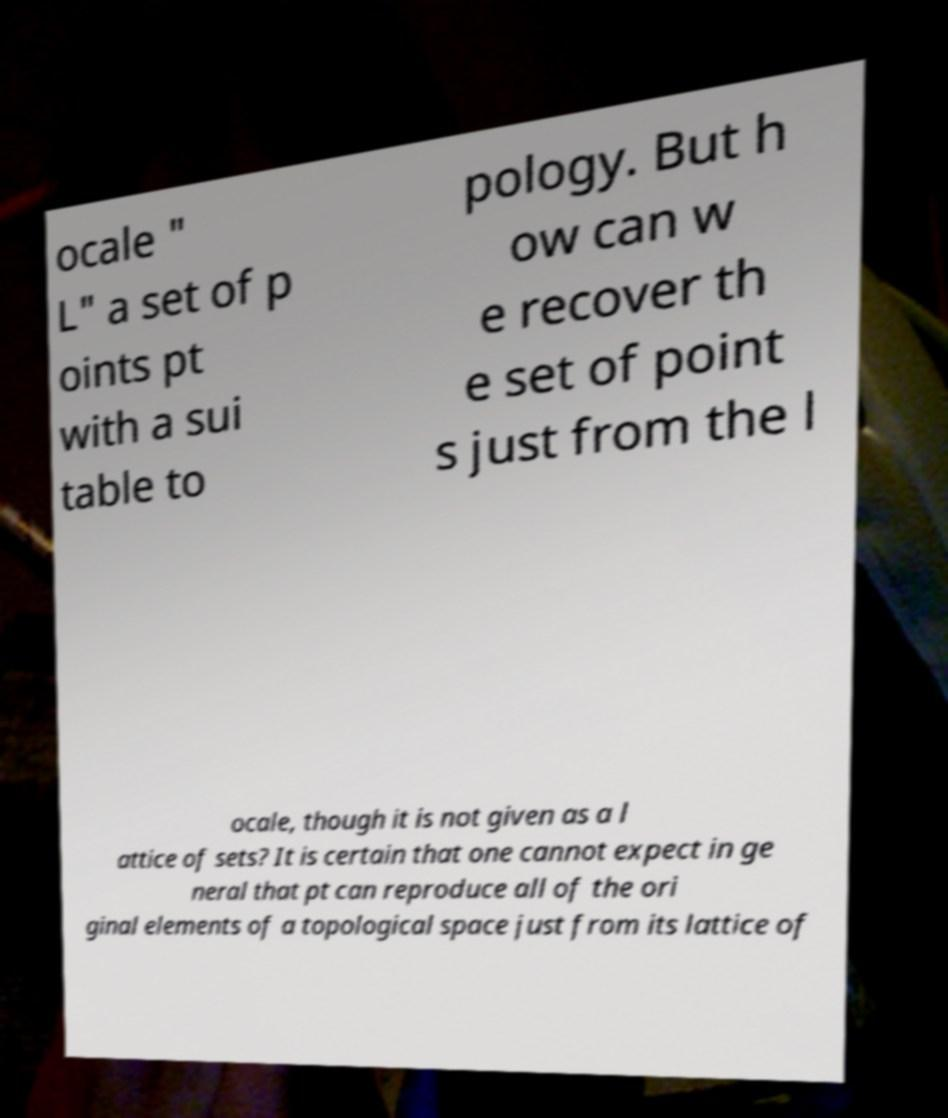Could you extract and type out the text from this image? ocale " L" a set of p oints pt with a sui table to pology. But h ow can w e recover th e set of point s just from the l ocale, though it is not given as a l attice of sets? It is certain that one cannot expect in ge neral that pt can reproduce all of the ori ginal elements of a topological space just from its lattice of 